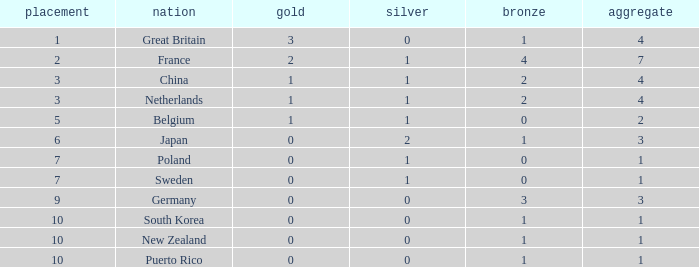What is the rank with 0 bronze? None. 